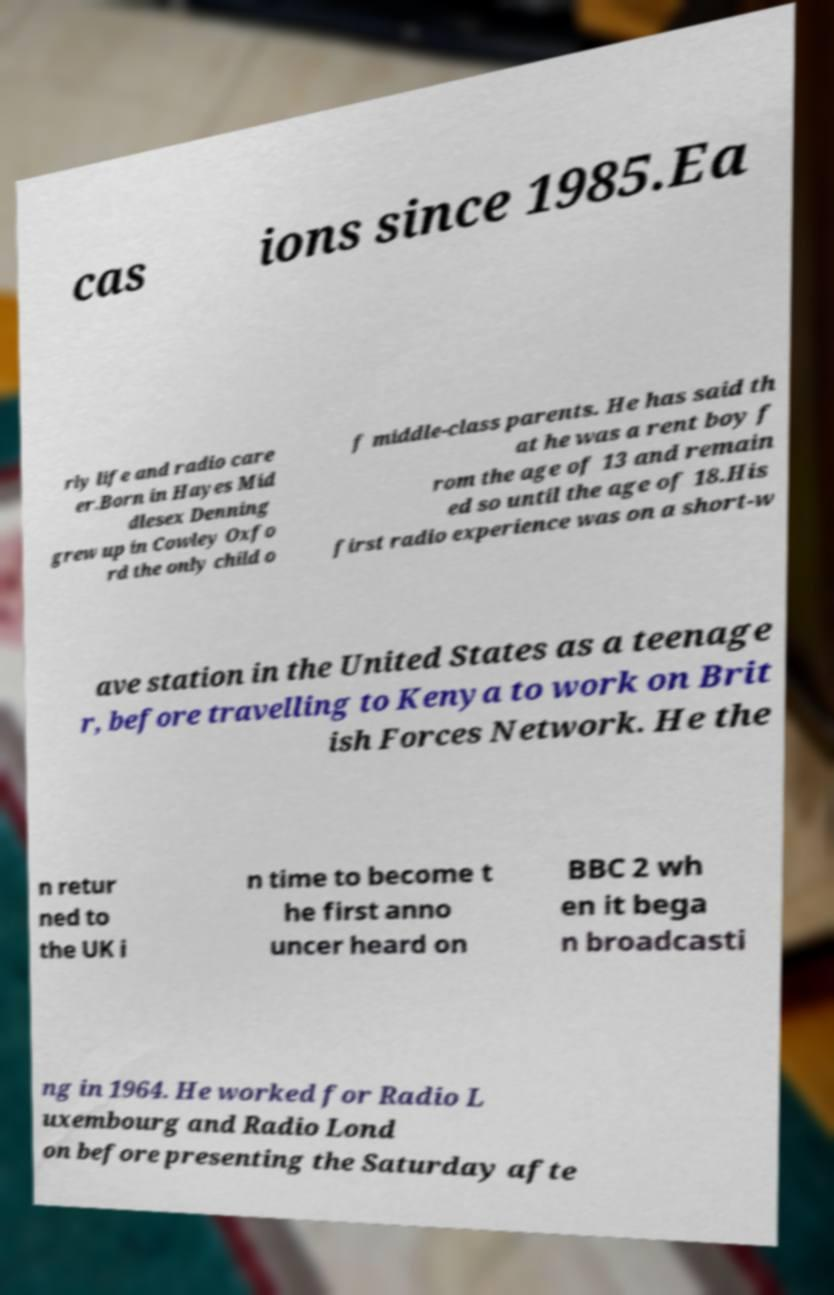Can you accurately transcribe the text from the provided image for me? cas ions since 1985.Ea rly life and radio care er.Born in Hayes Mid dlesex Denning grew up in Cowley Oxfo rd the only child o f middle-class parents. He has said th at he was a rent boy f rom the age of 13 and remain ed so until the age of 18.His first radio experience was on a short-w ave station in the United States as a teenage r, before travelling to Kenya to work on Brit ish Forces Network. He the n retur ned to the UK i n time to become t he first anno uncer heard on BBC 2 wh en it bega n broadcasti ng in 1964. He worked for Radio L uxembourg and Radio Lond on before presenting the Saturday afte 